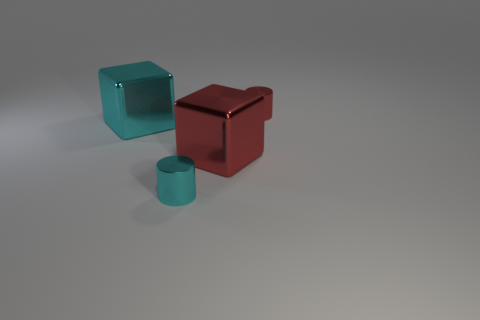Add 4 large gray spheres. How many objects exist? 8 Subtract 1 cylinders. How many cylinders are left? 1 Subtract all cyan blocks. Subtract all red balls. How many blocks are left? 1 Subtract all small yellow spheres. Subtract all metal blocks. How many objects are left? 2 Add 4 red metallic things. How many red metallic things are left? 6 Add 1 large gray shiny objects. How many large gray shiny objects exist? 1 Subtract 1 cyan blocks. How many objects are left? 3 